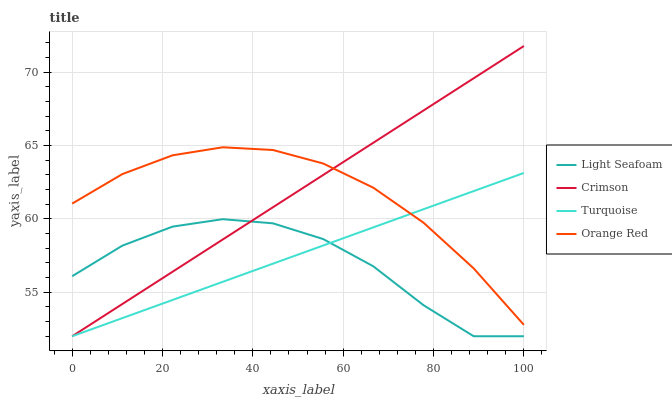Does Light Seafoam have the minimum area under the curve?
Answer yes or no. Yes. Does Crimson have the maximum area under the curve?
Answer yes or no. Yes. Does Turquoise have the minimum area under the curve?
Answer yes or no. No. Does Turquoise have the maximum area under the curve?
Answer yes or no. No. Is Turquoise the smoothest?
Answer yes or no. Yes. Is Light Seafoam the roughest?
Answer yes or no. Yes. Is Light Seafoam the smoothest?
Answer yes or no. No. Is Turquoise the roughest?
Answer yes or no. No. Does Crimson have the lowest value?
Answer yes or no. Yes. Does Orange Red have the lowest value?
Answer yes or no. No. Does Crimson have the highest value?
Answer yes or no. Yes. Does Turquoise have the highest value?
Answer yes or no. No. Is Light Seafoam less than Orange Red?
Answer yes or no. Yes. Is Orange Red greater than Light Seafoam?
Answer yes or no. Yes. Does Orange Red intersect Crimson?
Answer yes or no. Yes. Is Orange Red less than Crimson?
Answer yes or no. No. Is Orange Red greater than Crimson?
Answer yes or no. No. Does Light Seafoam intersect Orange Red?
Answer yes or no. No. 